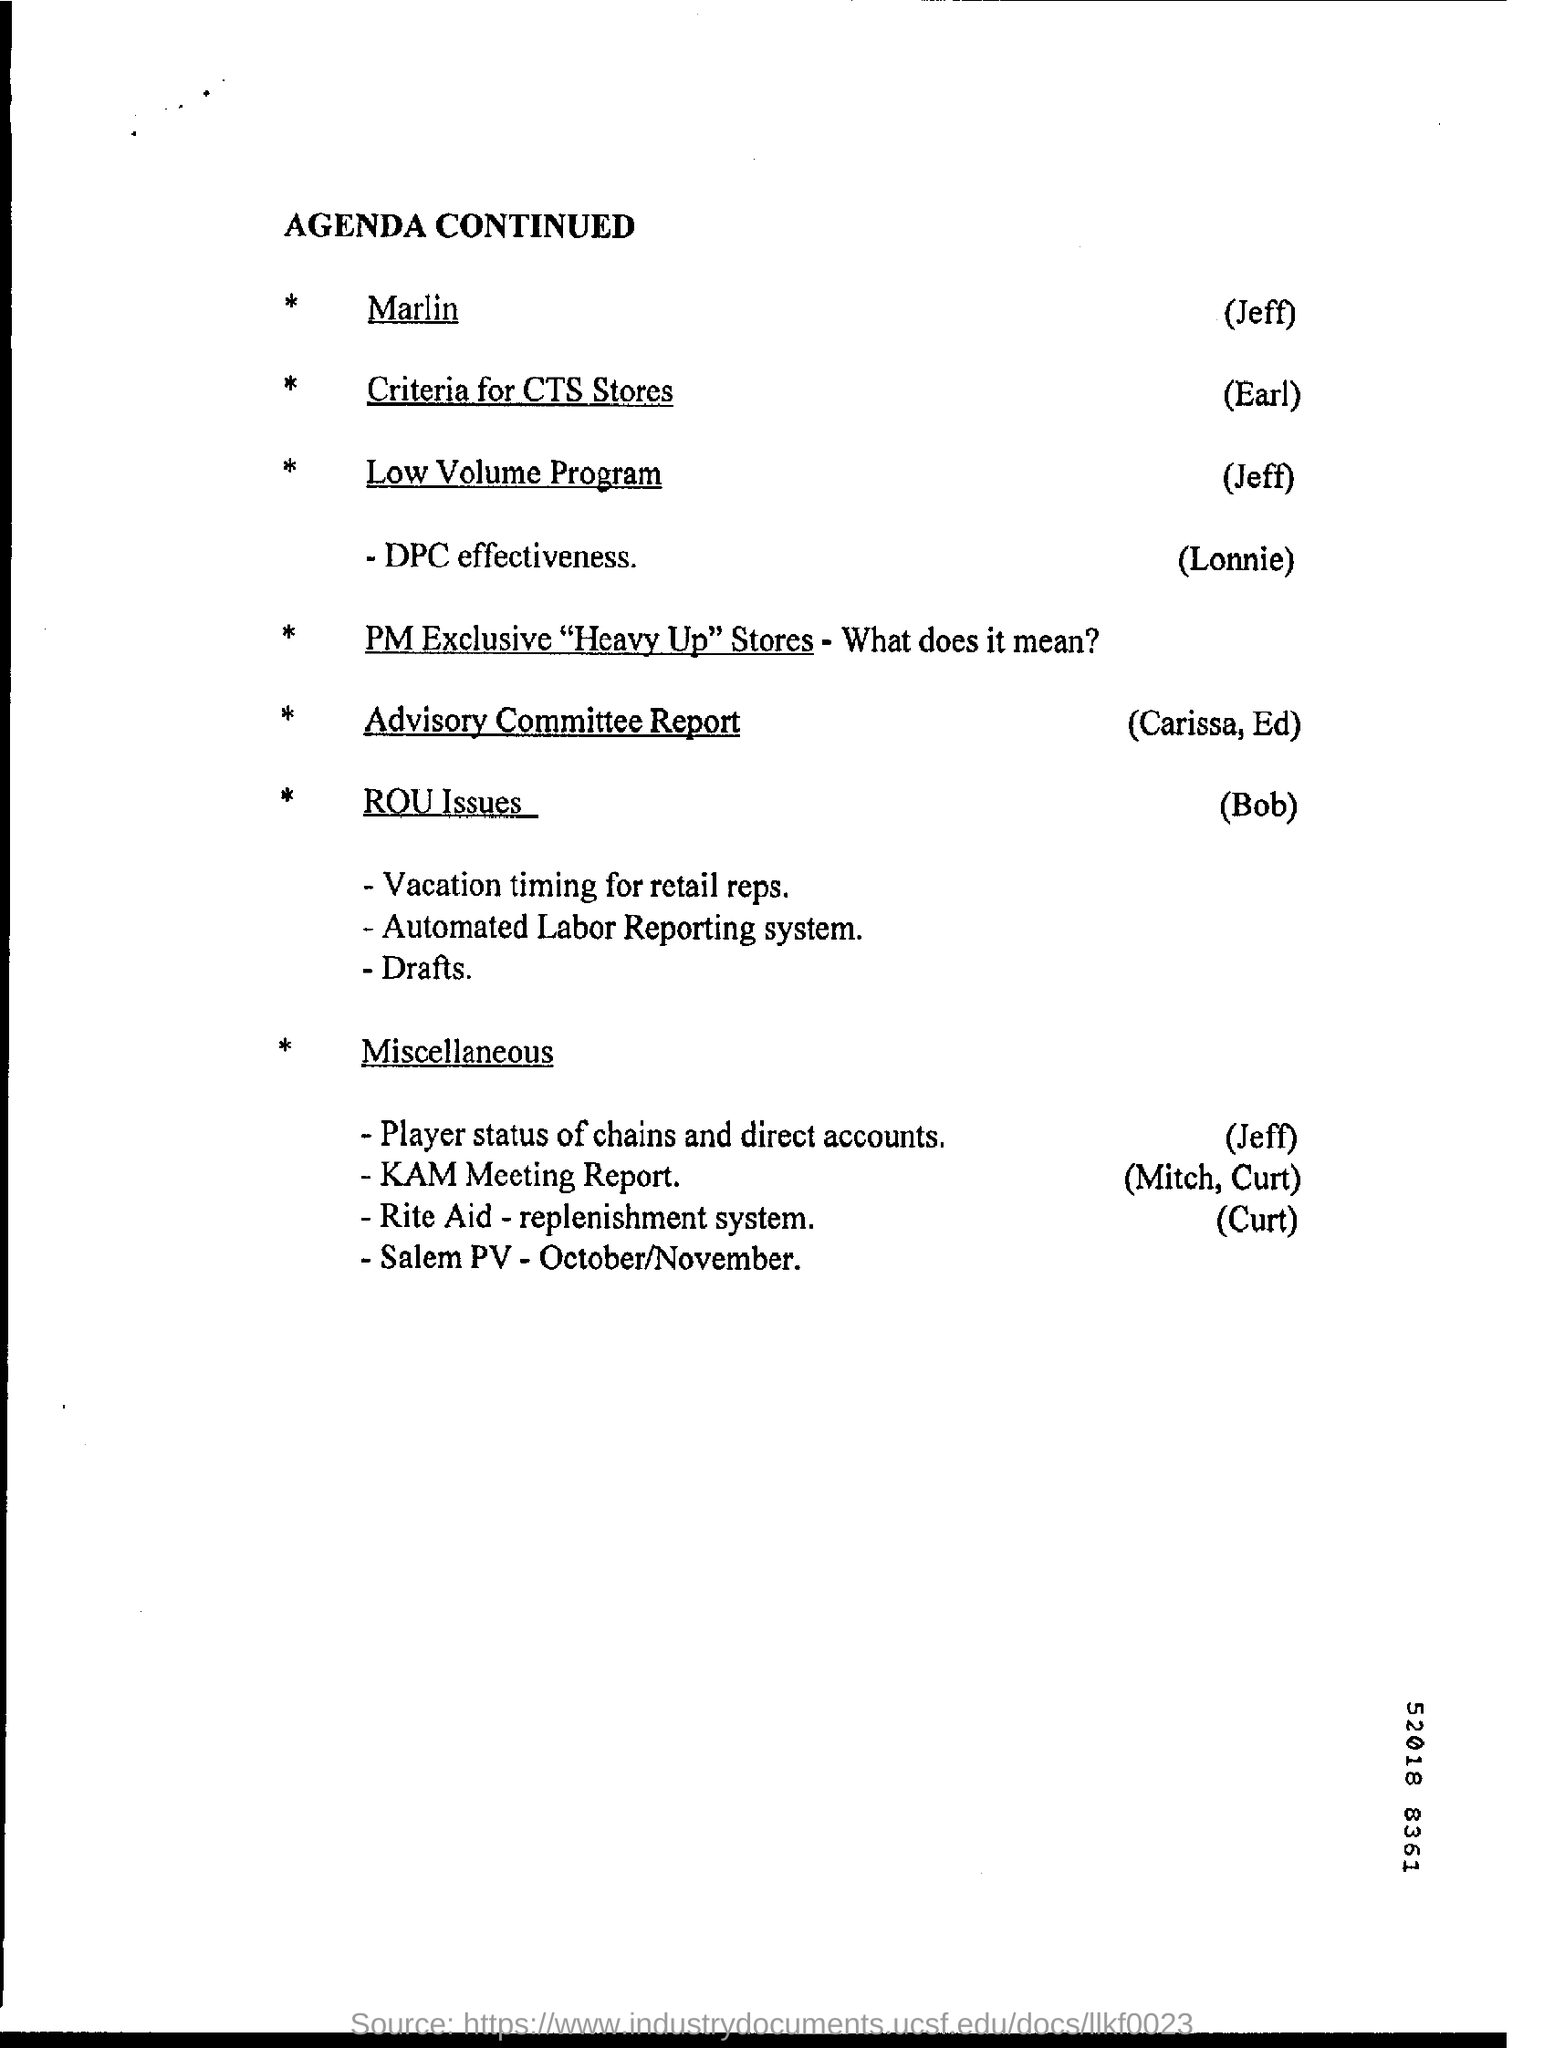What is the heading of the page ?
Make the answer very short. Agenda continued. 